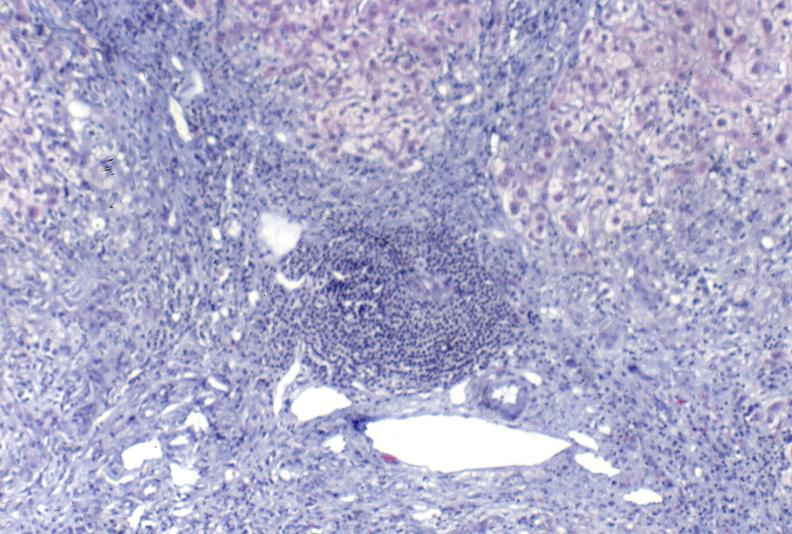s liver present?
Answer the question using a single word or phrase. Yes 